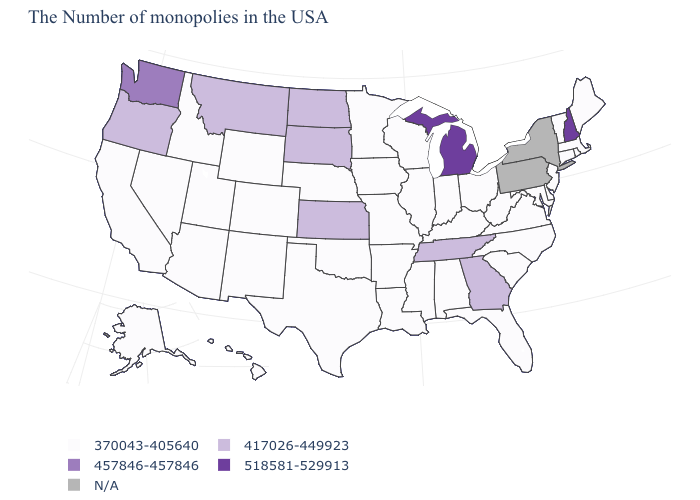What is the value of Delaware?
Short answer required. 370043-405640. Does the map have missing data?
Give a very brief answer. Yes. What is the value of Arizona?
Keep it brief. 370043-405640. What is the value of Montana?
Give a very brief answer. 417026-449923. Is the legend a continuous bar?
Answer briefly. No. Which states have the highest value in the USA?
Write a very short answer. New Hampshire, Michigan. Among the states that border Iowa , which have the highest value?
Write a very short answer. South Dakota. What is the lowest value in states that border Florida?
Answer briefly. 370043-405640. Which states have the lowest value in the USA?
Concise answer only. Maine, Massachusetts, Rhode Island, Vermont, Connecticut, New Jersey, Delaware, Maryland, Virginia, North Carolina, South Carolina, West Virginia, Ohio, Florida, Kentucky, Indiana, Alabama, Wisconsin, Illinois, Mississippi, Louisiana, Missouri, Arkansas, Minnesota, Iowa, Nebraska, Oklahoma, Texas, Wyoming, Colorado, New Mexico, Utah, Arizona, Idaho, Nevada, California, Alaska, Hawaii. What is the value of Pennsylvania?
Be succinct. N/A. What is the value of Alaska?
Give a very brief answer. 370043-405640. What is the value of North Dakota?
Concise answer only. 417026-449923. 